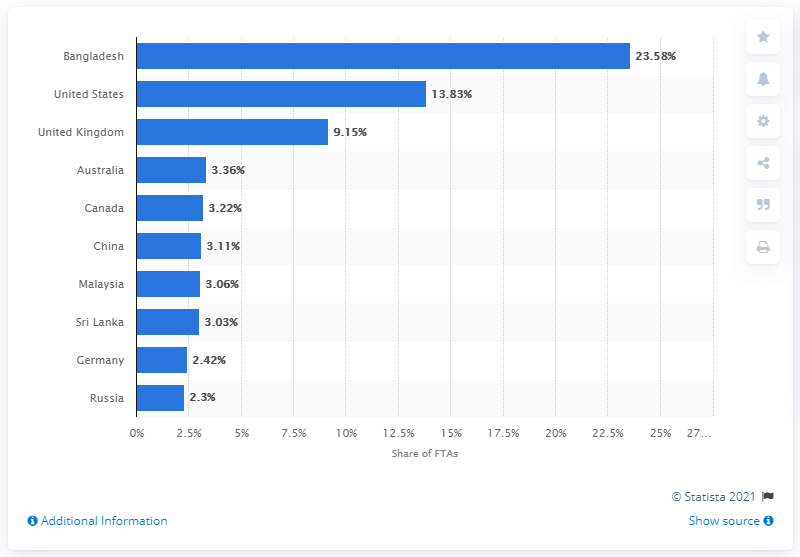Point out several critical features in this image. In 2019, the largest share of foreign tourist arrivals in India was accounted for by Bangladesh. 